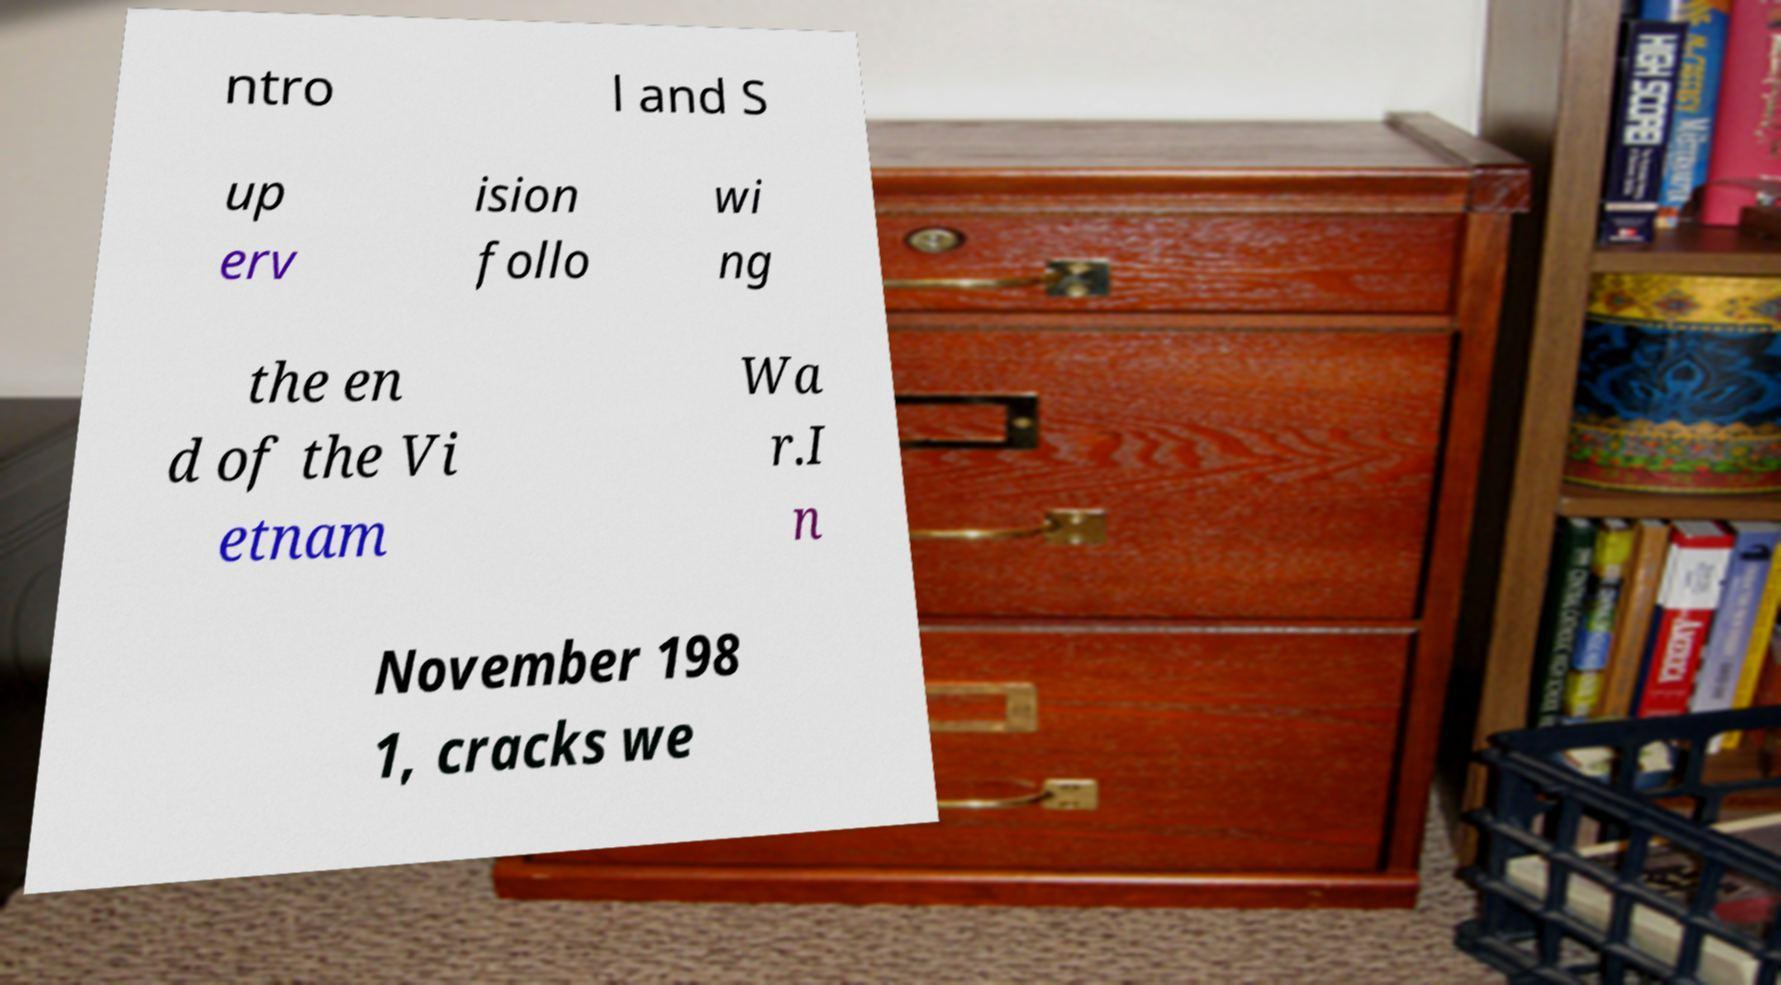Can you read and provide the text displayed in the image?This photo seems to have some interesting text. Can you extract and type it out for me? ntro l and S up erv ision follo wi ng the en d of the Vi etnam Wa r.I n November 198 1, cracks we 